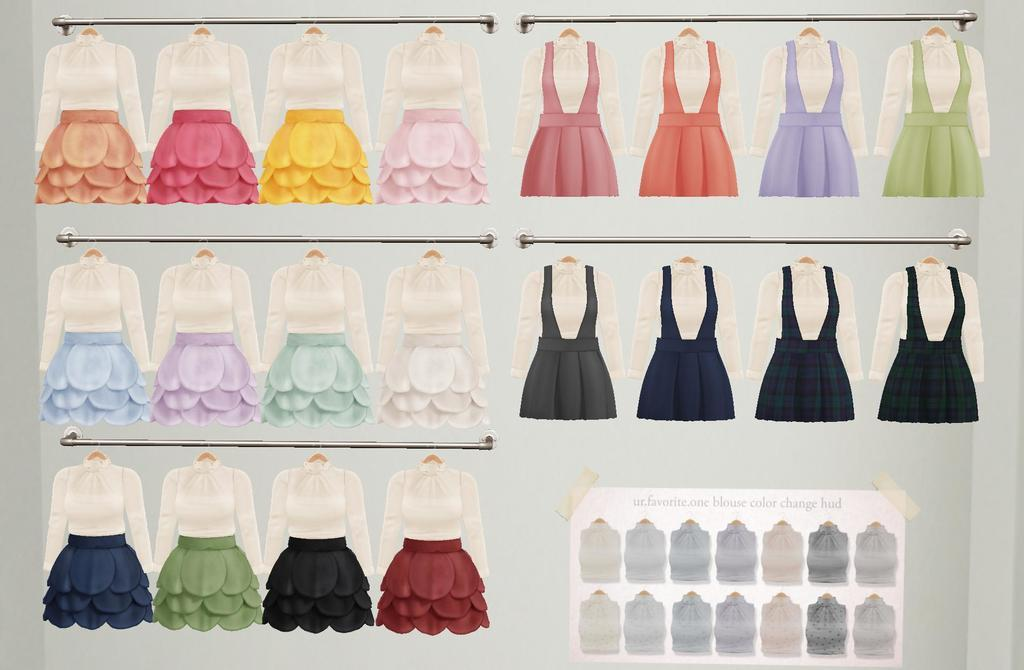What is the main subject of the poster in the image? The main subject of the poster in the image is clothes. What can be seen attached to the main poster? There is a poster with text and images of clothes attached to the main poster. What are the rods visible in the image used for? The rods visible in the image are likely used for hanging or displaying the clothes posters. Can you see anyone smashing the clothes in the image? There is no one smashing the clothes in the image; it only features posters of clothes. Is there a whip visible in the image? There is no whip present in the image. 